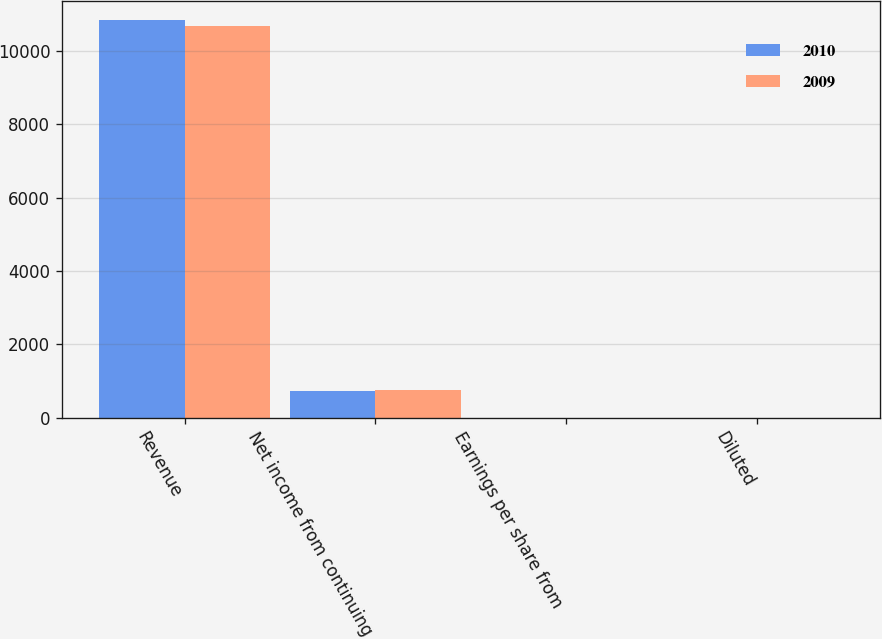Convert chart. <chart><loc_0><loc_0><loc_500><loc_500><stacked_bar_chart><ecel><fcel>Revenue<fcel>Net income from continuing<fcel>Earnings per share from<fcel>Diluted<nl><fcel>2010<fcel>10831<fcel>736<fcel>2.17<fcel>2.14<nl><fcel>2009<fcel>10669<fcel>758<fcel>2.2<fcel>2.15<nl></chart> 